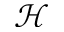<formula> <loc_0><loc_0><loc_500><loc_500>\mathcal { H }</formula> 